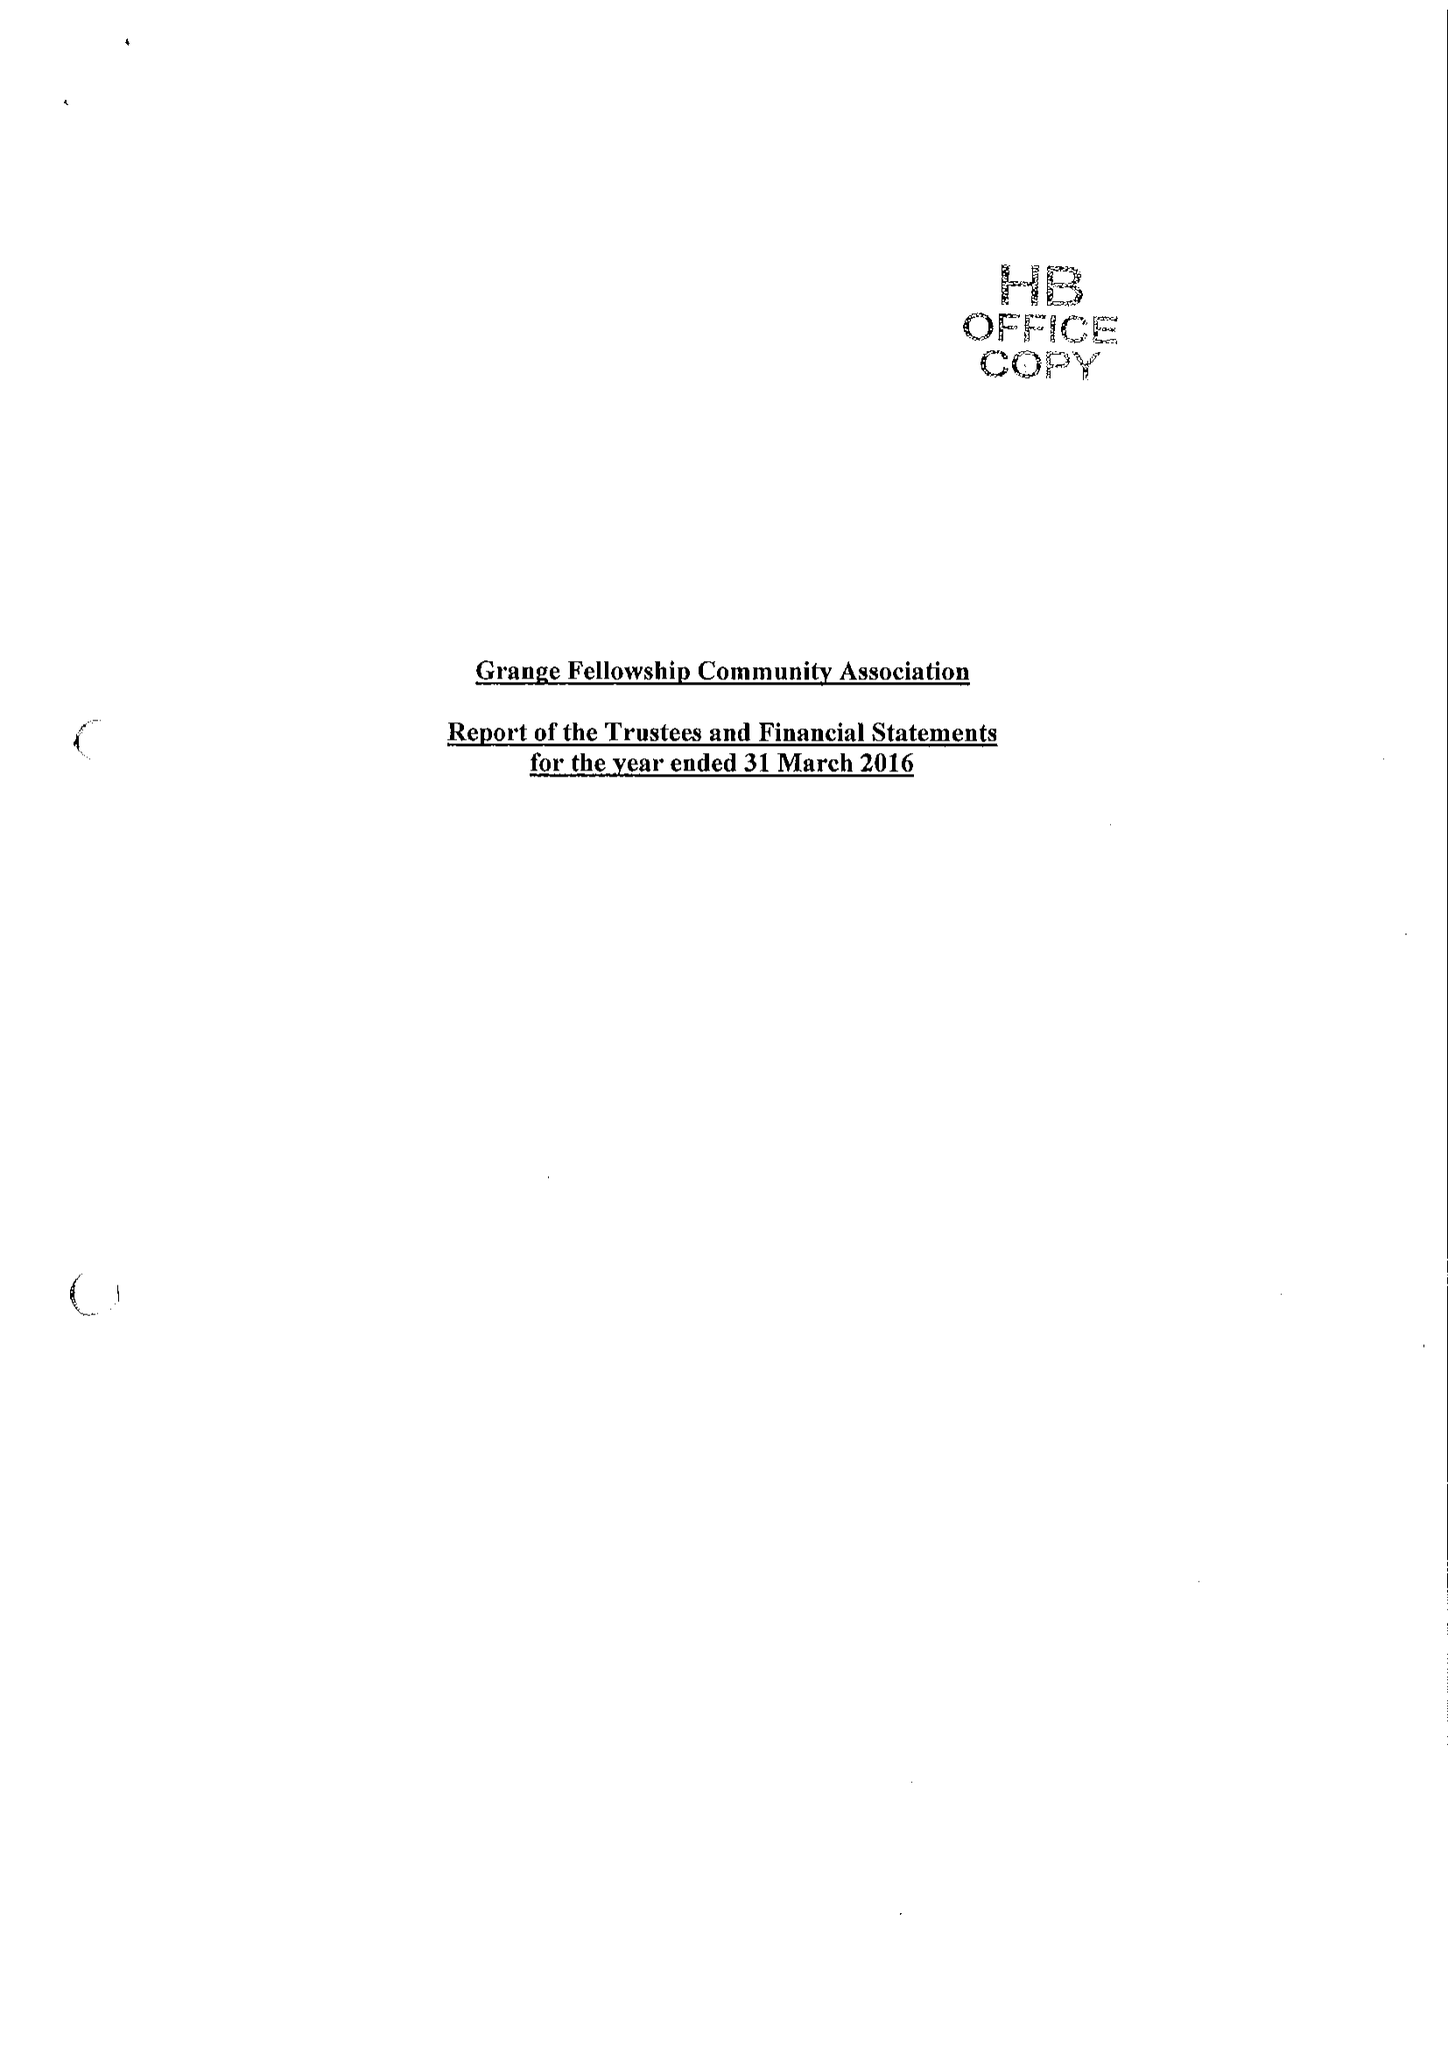What is the value for the address__post_town?
Answer the question using a single word or phrase. LETCHWORTH GARDEN CITY 